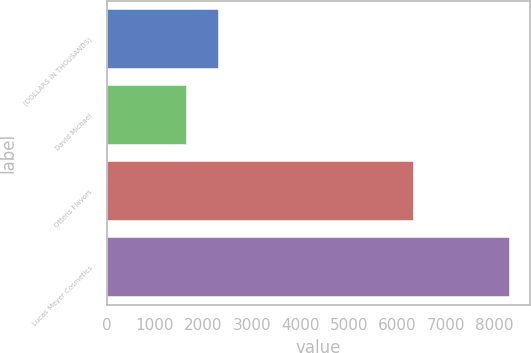<chart> <loc_0><loc_0><loc_500><loc_500><bar_chart><fcel>(DOLLARS IN THOUSANDS)<fcel>David Michael<fcel>Ottens Flavors<fcel>Lucas Meyer Cosmetics<nl><fcel>2328<fcel>1662<fcel>6345<fcel>8322<nl></chart> 